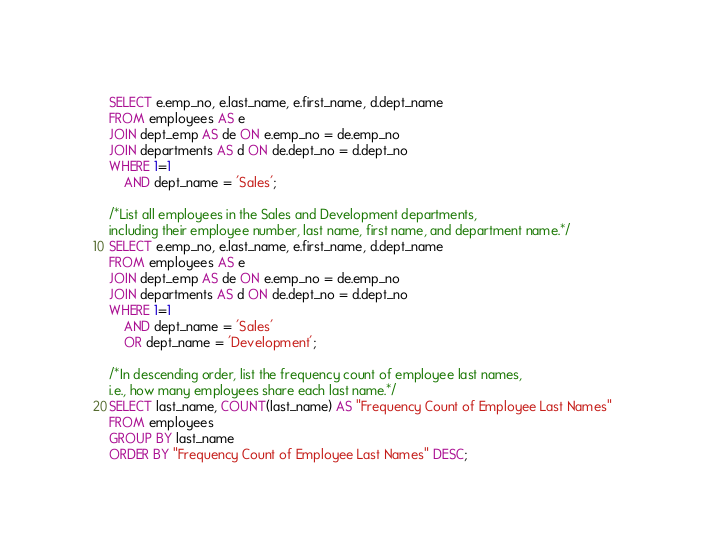Convert code to text. <code><loc_0><loc_0><loc_500><loc_500><_SQL_>SELECT e.emp_no, e.last_name, e.first_name, d.dept_name
FROM employees AS e
JOIN dept_emp AS de ON e.emp_no = de.emp_no
JOIN departments AS d ON de.dept_no = d.dept_no
WHERE 1=1
	AND dept_name = 'Sales';

/*List all employees in the Sales and Development departments,
including their employee number, last name, first name, and department name.*/
SELECT e.emp_no, e.last_name, e.first_name, d.dept_name
FROM employees AS e
JOIN dept_emp AS de ON e.emp_no = de.emp_no
JOIN departments AS d ON de.dept_no = d.dept_no
WHERE 1=1
	AND dept_name = 'Sales'
	OR dept_name = 'Development';

/*In descending order, list the frequency count of employee last names,
i.e., how many employees share each last name.*/
SELECT last_name, COUNT(last_name) AS "Frequency Count of Employee Last Names"
FROM employees
GROUP BY last_name
ORDER BY "Frequency Count of Employee Last Names" DESC;</code> 